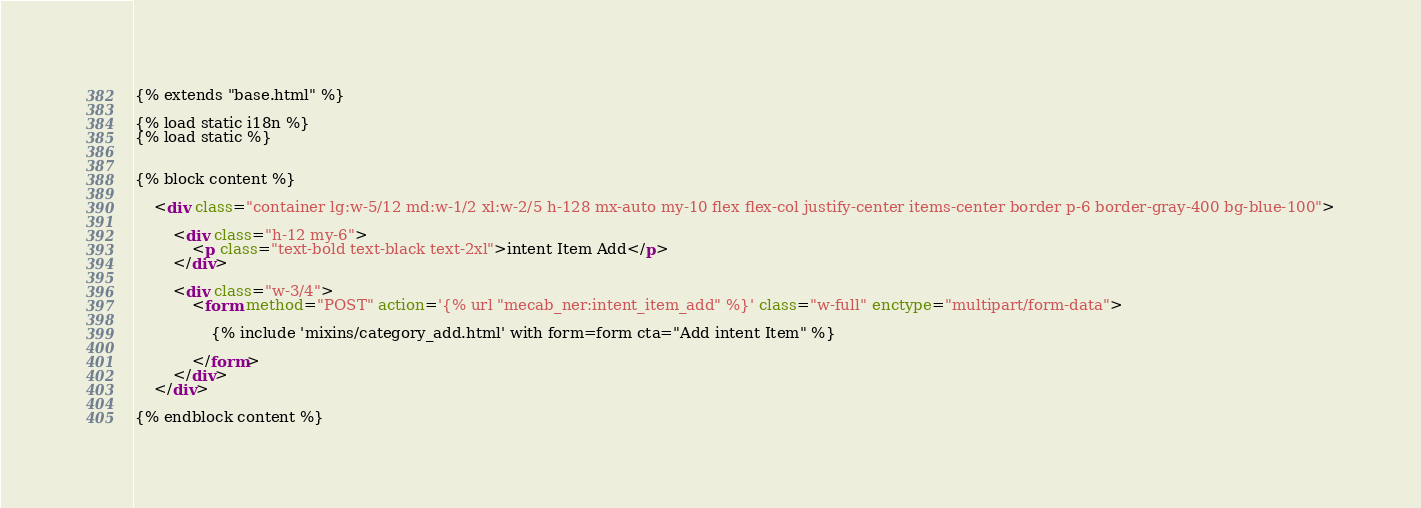Convert code to text. <code><loc_0><loc_0><loc_500><loc_500><_HTML_>{% extends "base.html" %}

{% load static i18n %}
{% load static %}


{% block content %}

    <div class="container lg:w-5/12 md:w-1/2 xl:w-2/5 h-128 mx-auto my-10 flex flex-col justify-center items-center border p-6 border-gray-400 bg-blue-100">

        <div class="h-12 my-6">
            <p class="text-bold text-black text-2xl">intent Item Add</p>
        </div>

        <div class="w-3/4">
            <form method="POST" action='{% url "mecab_ner:intent_item_add" %}' class="w-full" enctype="multipart/form-data">

                {% include 'mixins/category_add.html' with form=form cta="Add intent Item" %}

            </form>
        </div>
    </div>

{% endblock content %}</code> 